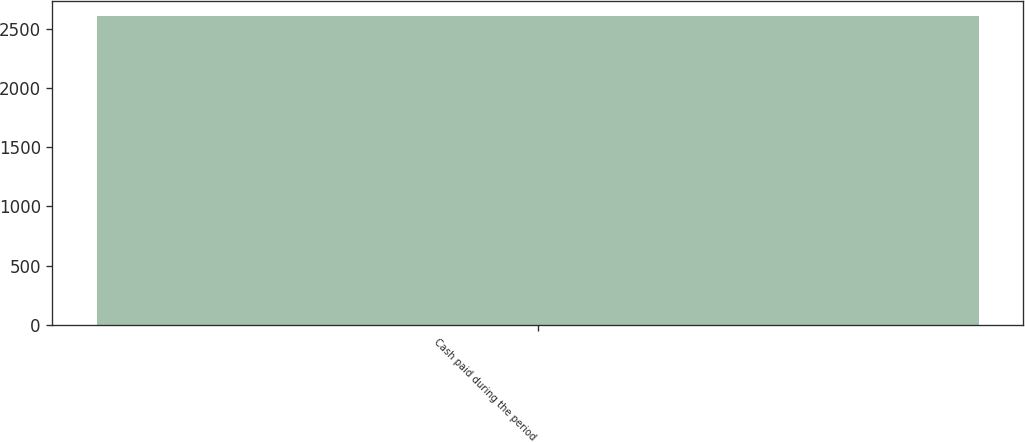<chart> <loc_0><loc_0><loc_500><loc_500><bar_chart><fcel>Cash paid during the period<nl><fcel>2609<nl></chart> 